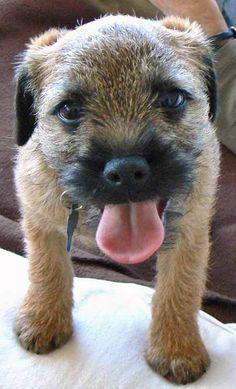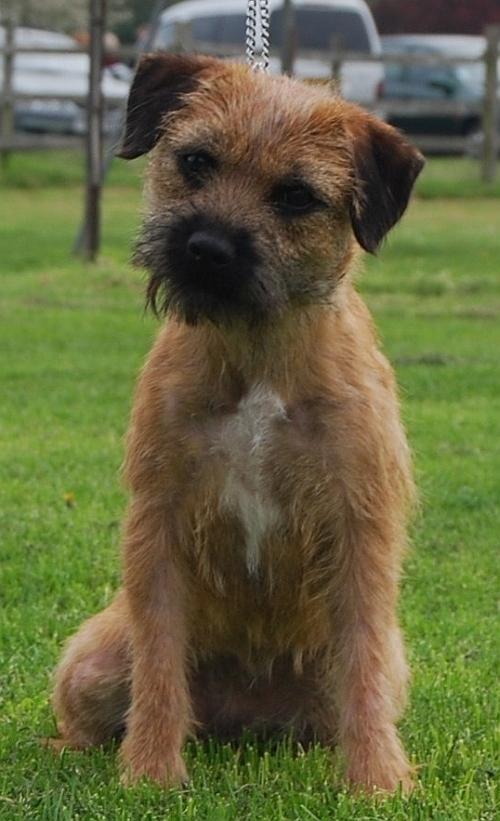The first image is the image on the left, the second image is the image on the right. For the images displayed, is the sentence "One dog is sitting in the grass." factually correct? Answer yes or no. Yes. The first image is the image on the left, the second image is the image on the right. Examine the images to the left and right. Is the description "One dog's tongue is hanging out of its mouth." accurate? Answer yes or no. Yes. 